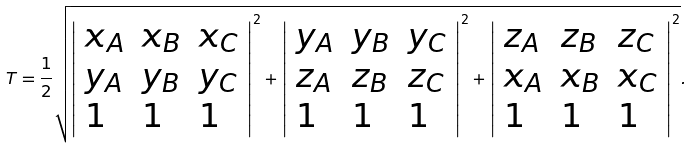Convert formula to latex. <formula><loc_0><loc_0><loc_500><loc_500>T = { \frac { 1 } { 2 } } { \sqrt { { \left | \begin{array} { l l l } { x _ { A } } & { x _ { B } } & { x _ { C } } \\ { y _ { A } } & { y _ { B } } & { y _ { C } } \\ { 1 } & { 1 } & { 1 } \end{array} \right | } ^ { 2 } + { \left | \begin{array} { l l l } { y _ { A } } & { y _ { B } } & { y _ { C } } \\ { z _ { A } } & { z _ { B } } & { z _ { C } } \\ { 1 } & { 1 } & { 1 } \end{array} \right | } ^ { 2 } + { \left | \begin{array} { l l l } { z _ { A } } & { z _ { B } } & { z _ { C } } \\ { x _ { A } } & { x _ { B } } & { x _ { C } } \\ { 1 } & { 1 } & { 1 } \end{array} \right | } ^ { 2 } } } .</formula> 